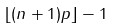Convert formula to latex. <formula><loc_0><loc_0><loc_500><loc_500>\lfloor ( n + 1 ) p \rfloor - 1</formula> 